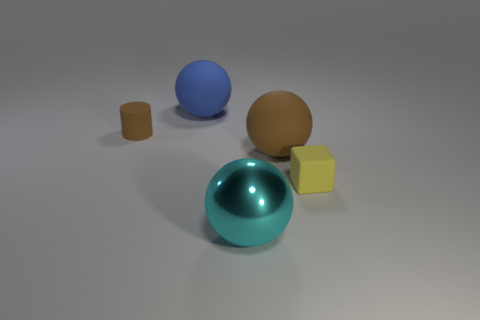Can you describe the positioning of the objects in relation to each other? There are four objects arranged seemingly at random on a flat surface. The large cyan sphere is centrally located, slightly to the back. In front of it lies one tiny matte cylinder, and to the sphere's left is a smaller sphere. To the right, we have a cube that is near and to the foreground relative to the large cyan sphere. 